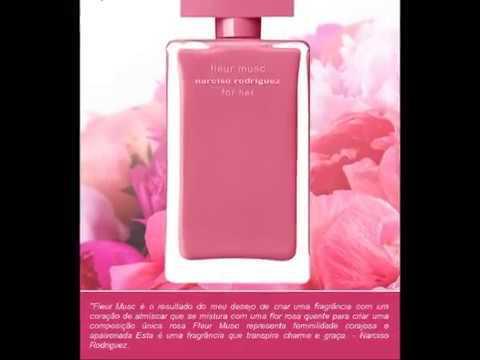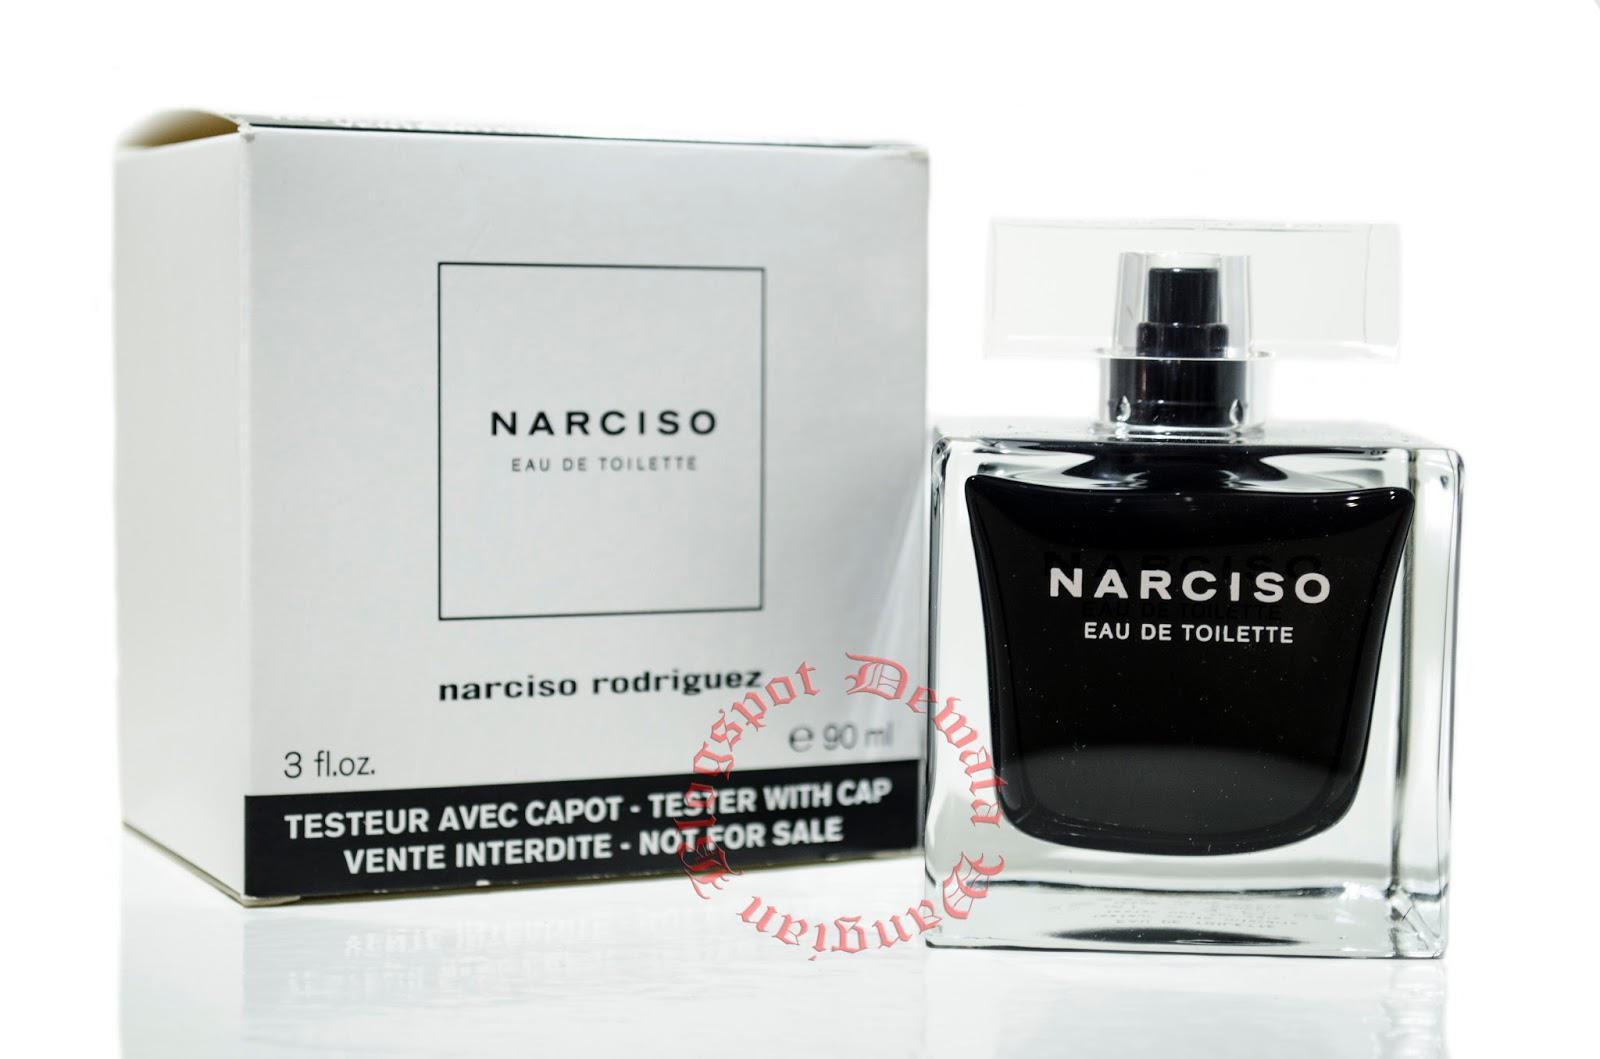The first image is the image on the left, the second image is the image on the right. Assess this claim about the two images: "No single image contains more than one fragrance bottle, and the bottles on the left and right are at least very similar in size, shape, and color.". Correct or not? Answer yes or no. No. 